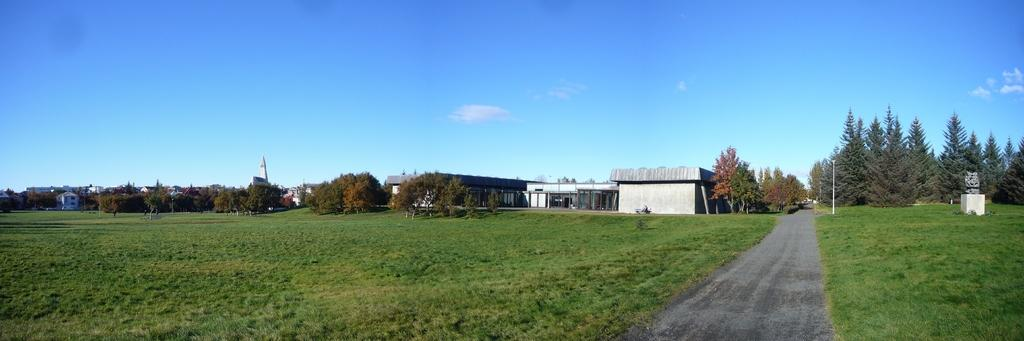What is the main feature of the image? There is a road in the image. What can be seen on either side of the road? There are trees and greenery ground on either side of the road. What is visible in the background of the image? There are buildings in the background of the image. How many feet are visible in the image? There are no feet visible in the image. What type of cup is being used to water the plants in the image? There is no cup or watering of plants depicted in the image. 